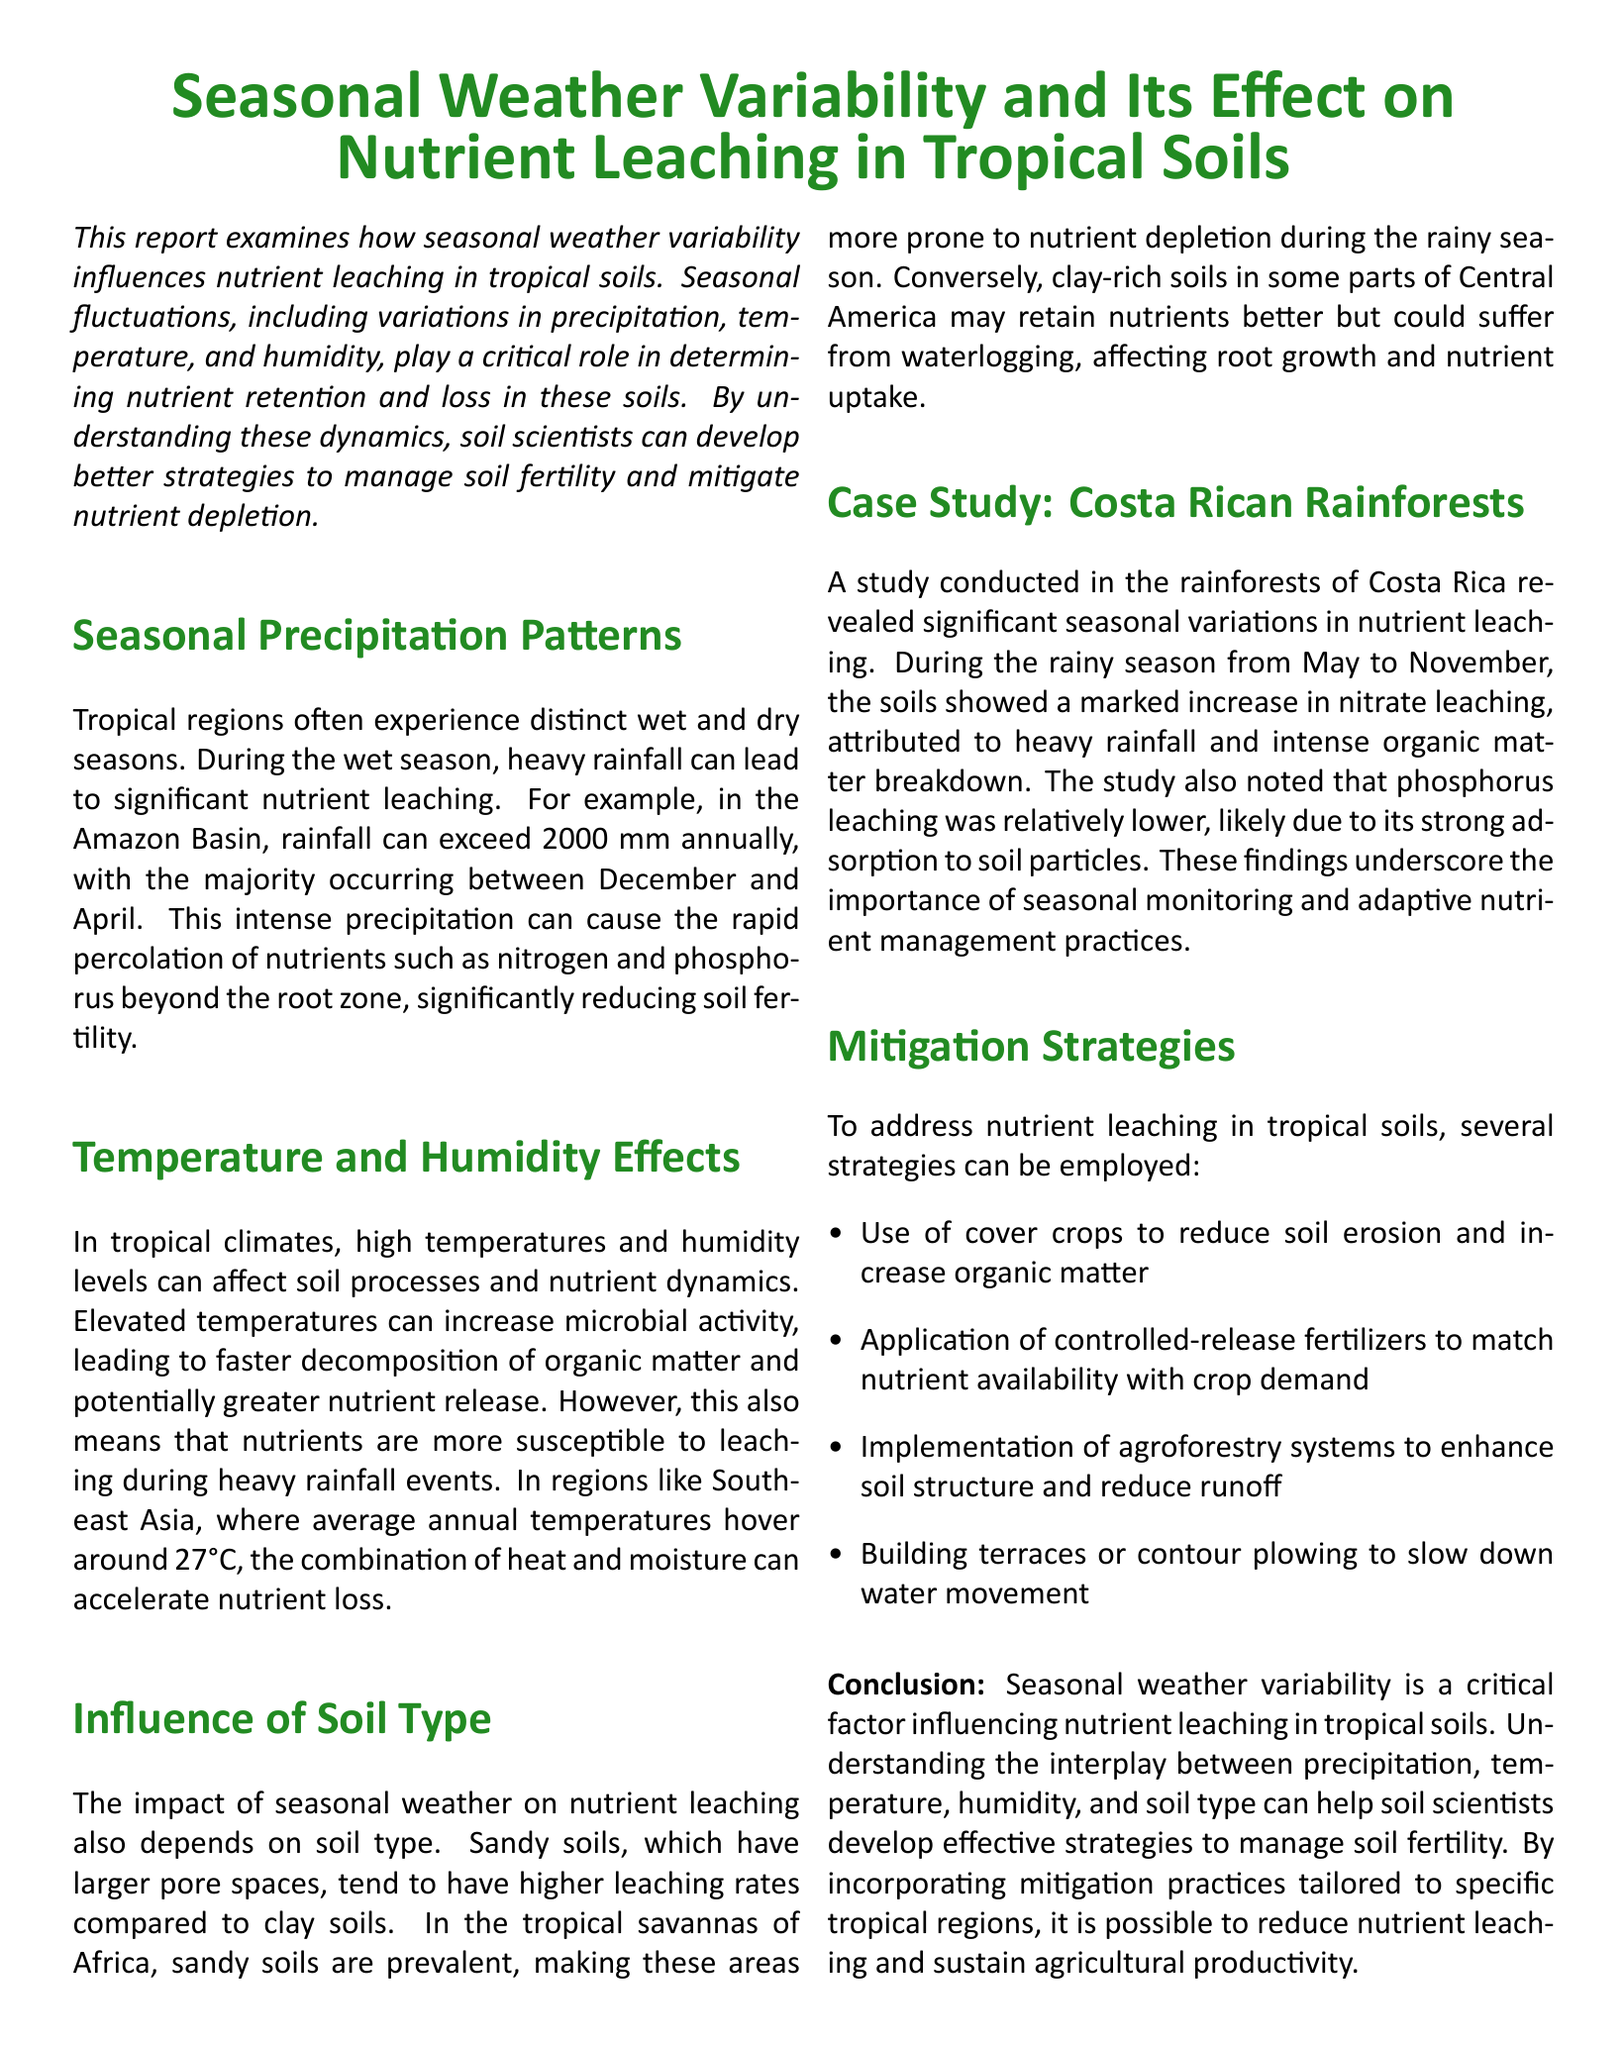What is the annual rainfall in the Amazon Basin? The document states that rainfall can exceed 2000 mm annually in the Amazon Basin.
Answer: 2000 mm During which months does the majority of rainfall occur in the Amazon Basin? The report indicates that the majority of rainfall occurs between December and April.
Answer: December to April What temperature do average annual temperatures hover around in Southeast Asia? The document notes that average annual temperatures in Southeast Asia are around 27°C.
Answer: 27°C Which soil type tends to have higher leaching rates? The report mentions that sandy soils, which have larger pore spaces, tend to have higher leaching rates.
Answer: Sandy soils What was a significant finding in the Costa Rican rainforest study regarding nitrate leaching? The study found a marked increase in nitrate leaching during the rainy season attributed to heavy rainfall and intense organic matter breakdown.
Answer: Marked increase in nitrate leaching What mitigation strategy can be used to reduce soil erosion? The document suggests the use of cover crops to reduce soil erosion.
Answer: Cover crops What is one effect of elevated temperatures mentioned in the report? Elevated temperatures can increase microbial activity, leading to faster decomposition of organic matter.
Answer: Faster decomposition of organic matter What component is less leached due to its strong adsorption to soil particles? The report states that phosphorus leaching was relatively lower, likely due to its strong adsorption to soil particles.
Answer: Phosphorus What does the document suggest to enhance soil structure? The document recommends implementing agroforestry systems to enhance soil structure.
Answer: Agroforestry systems 